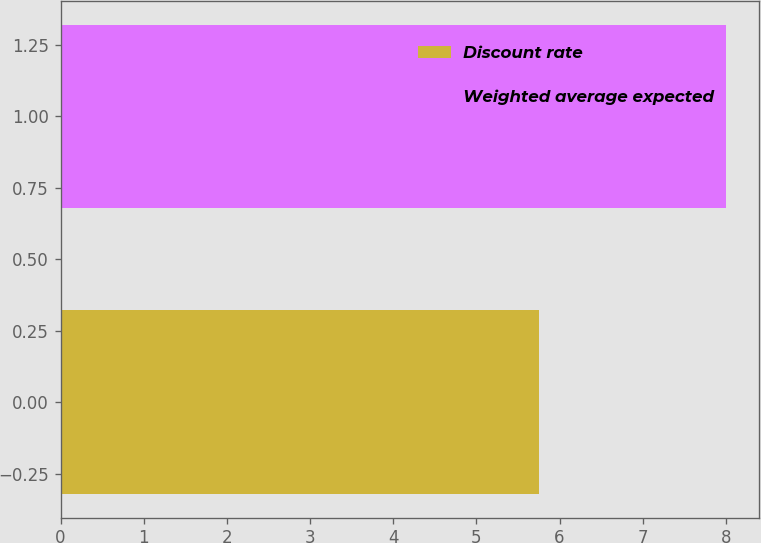Convert chart to OTSL. <chart><loc_0><loc_0><loc_500><loc_500><bar_chart><fcel>Discount rate<fcel>Weighted average expected<nl><fcel>5.75<fcel>8<nl></chart> 